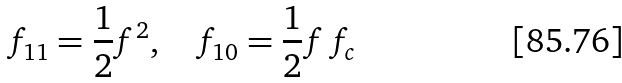<formula> <loc_0><loc_0><loc_500><loc_500>f _ { 1 1 } = \frac { 1 } { 2 } f ^ { 2 } , \quad f _ { 1 0 } = \frac { 1 } { 2 } f \, f _ { c }</formula> 